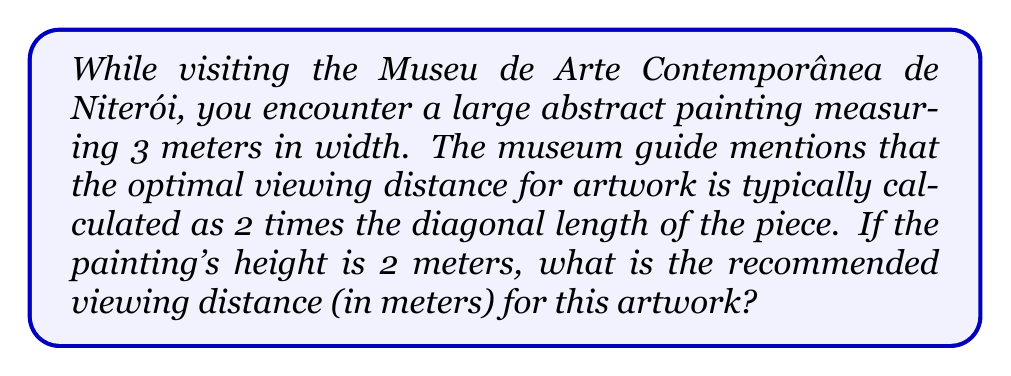Help me with this question. To solve this problem, we'll follow these steps:

1. Calculate the diagonal length of the painting using the Pythagorean theorem.
2. Multiply the diagonal length by 2 to find the optimal viewing distance.

Step 1: Calculate the diagonal length
Let's use the Pythagorean theorem: $a^2 + b^2 = c^2$, where $a$ is the width, $b$ is the height, and $c$ is the diagonal.

$$ a = 3 \text{ meters} $$
$$ b = 2 \text{ meters} $$

$$ c^2 = a^2 + b^2 $$
$$ c^2 = 3^2 + 2^2 $$
$$ c^2 = 9 + 4 = 13 $$
$$ c = \sqrt{13} \text{ meters} $$

Step 2: Calculate the optimal viewing distance
The optimal viewing distance is 2 times the diagonal length:

$$ \text{Optimal Distance} = 2 \times \sqrt{13} \text{ meters} $$

To simplify:
$$ 2\sqrt{13} \approx 7.21 \text{ meters} $$

Therefore, the recommended viewing distance is approximately 7.21 meters.
Answer: $2\sqrt{13} \approx 7.21 \text{ meters}$ 